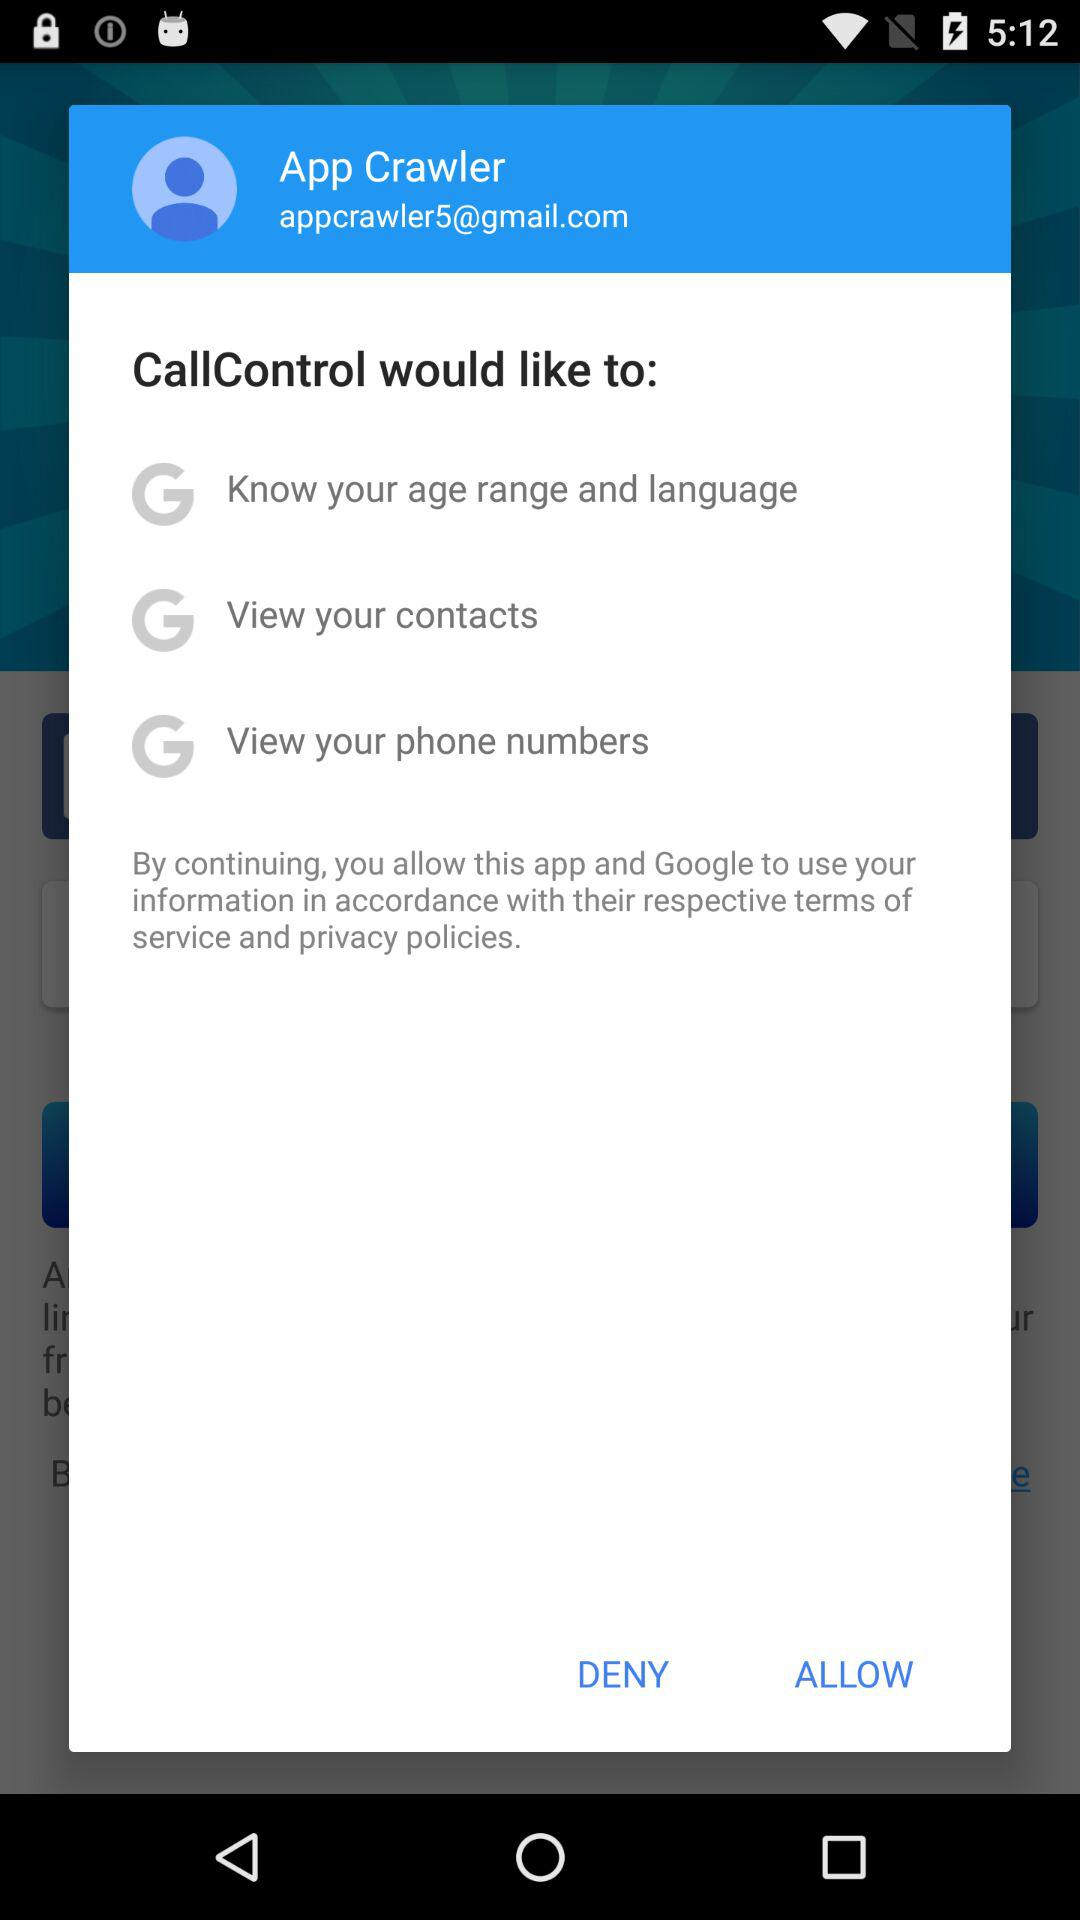What is the user name? The user name is App Crawler. 